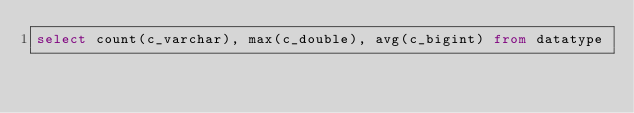Convert code to text. <code><loc_0><loc_0><loc_500><loc_500><_SQL_>select count(c_varchar), max(c_double), avg(c_bigint) from datatype
</code> 